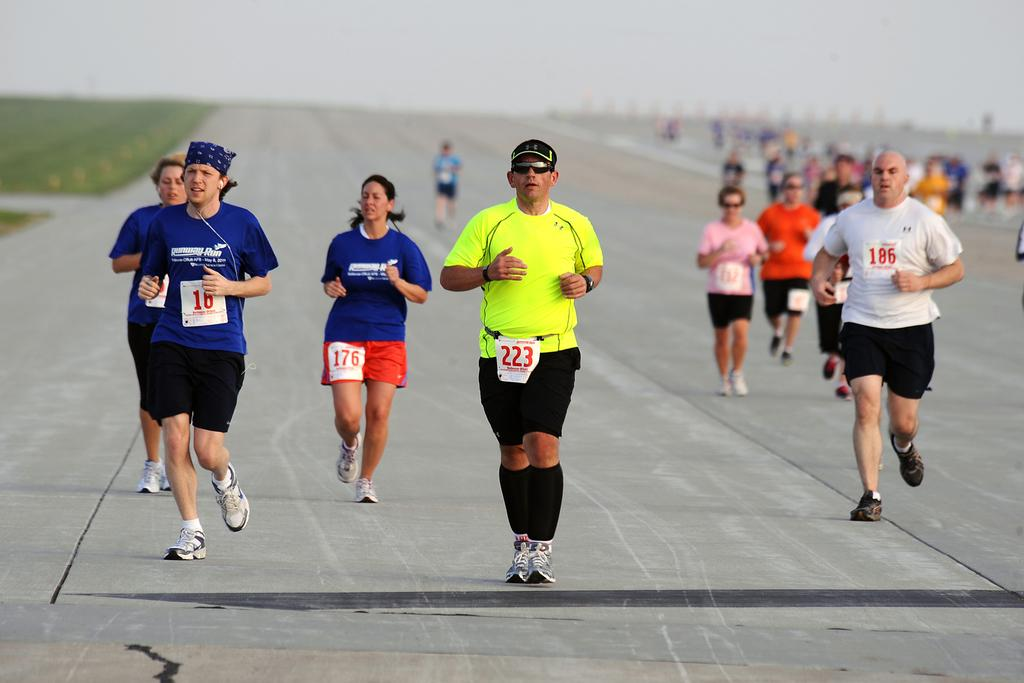What is the main feature of the image? There is a road in the image. What are the people on the road doing? The people are jogging on the road. What can be seen in the background of the image? The sky is visible in the background of the image. How many women are present in the image? There is no information about the gender of the people in the image, so we cannot determine the number of women. What type of growth can be seen on the road in the image? There is no growth visible on the road in the image. 